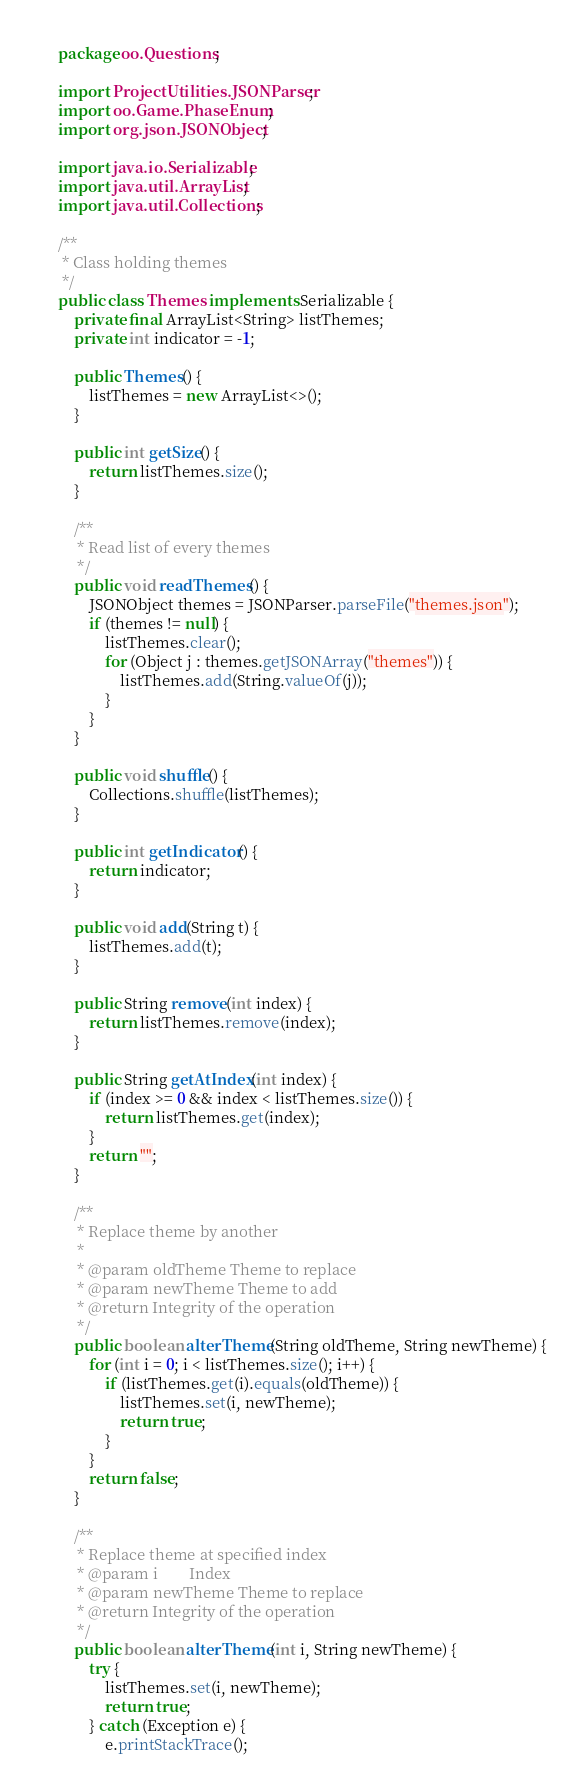Convert code to text. <code><loc_0><loc_0><loc_500><loc_500><_Java_>package oo.Questions;

import ProjectUtilities.JSONParser;
import oo.Game.PhaseEnum;
import org.json.JSONObject;

import java.io.Serializable;
import java.util.ArrayList;
import java.util.Collections;

/**
 * Class holding themes
 */
public class Themes implements Serializable {
    private final ArrayList<String> listThemes;
    private int indicator = -1;

    public Themes() {
        listThemes = new ArrayList<>();
    }

    public int getSize() {
        return listThemes.size();
    }

    /**
     * Read list of every themes
     */
    public void readThemes() {
        JSONObject themes = JSONParser.parseFile("themes.json");
        if (themes != null) {
            listThemes.clear();
            for (Object j : themes.getJSONArray("themes")) {
                listThemes.add(String.valueOf(j));
            }
        }
    }

    public void shuffle() {
        Collections.shuffle(listThemes);
    }

    public int getIndicator() {
        return indicator;
    }

    public void add(String t) {
        listThemes.add(t);
    }

    public String remove(int index) {
        return listThemes.remove(index);
    }

    public String getAtIndex(int index) {
        if (index >= 0 && index < listThemes.size()) {
            return listThemes.get(index);
        }
        return "";
    }

    /**
     * Replace theme by another
     *
     * @param oldTheme Theme to replace
     * @param newTheme Theme to add
     * @return Integrity of the operation
     */
    public boolean alterTheme(String oldTheme, String newTheme) {
        for (int i = 0; i < listThemes.size(); i++) {
            if (listThemes.get(i).equals(oldTheme)) {
                listThemes.set(i, newTheme);
                return true;
            }
        }
        return false;
    }

    /**
     * Replace theme at specified index
     * @param i        Index
     * @param newTheme Theme to replace
     * @return Integrity of the operation
     */
    public boolean alterTheme(int i, String newTheme) {
        try {
            listThemes.set(i, newTheme);
            return true;
        } catch (Exception e) {
            e.printStackTrace();</code> 